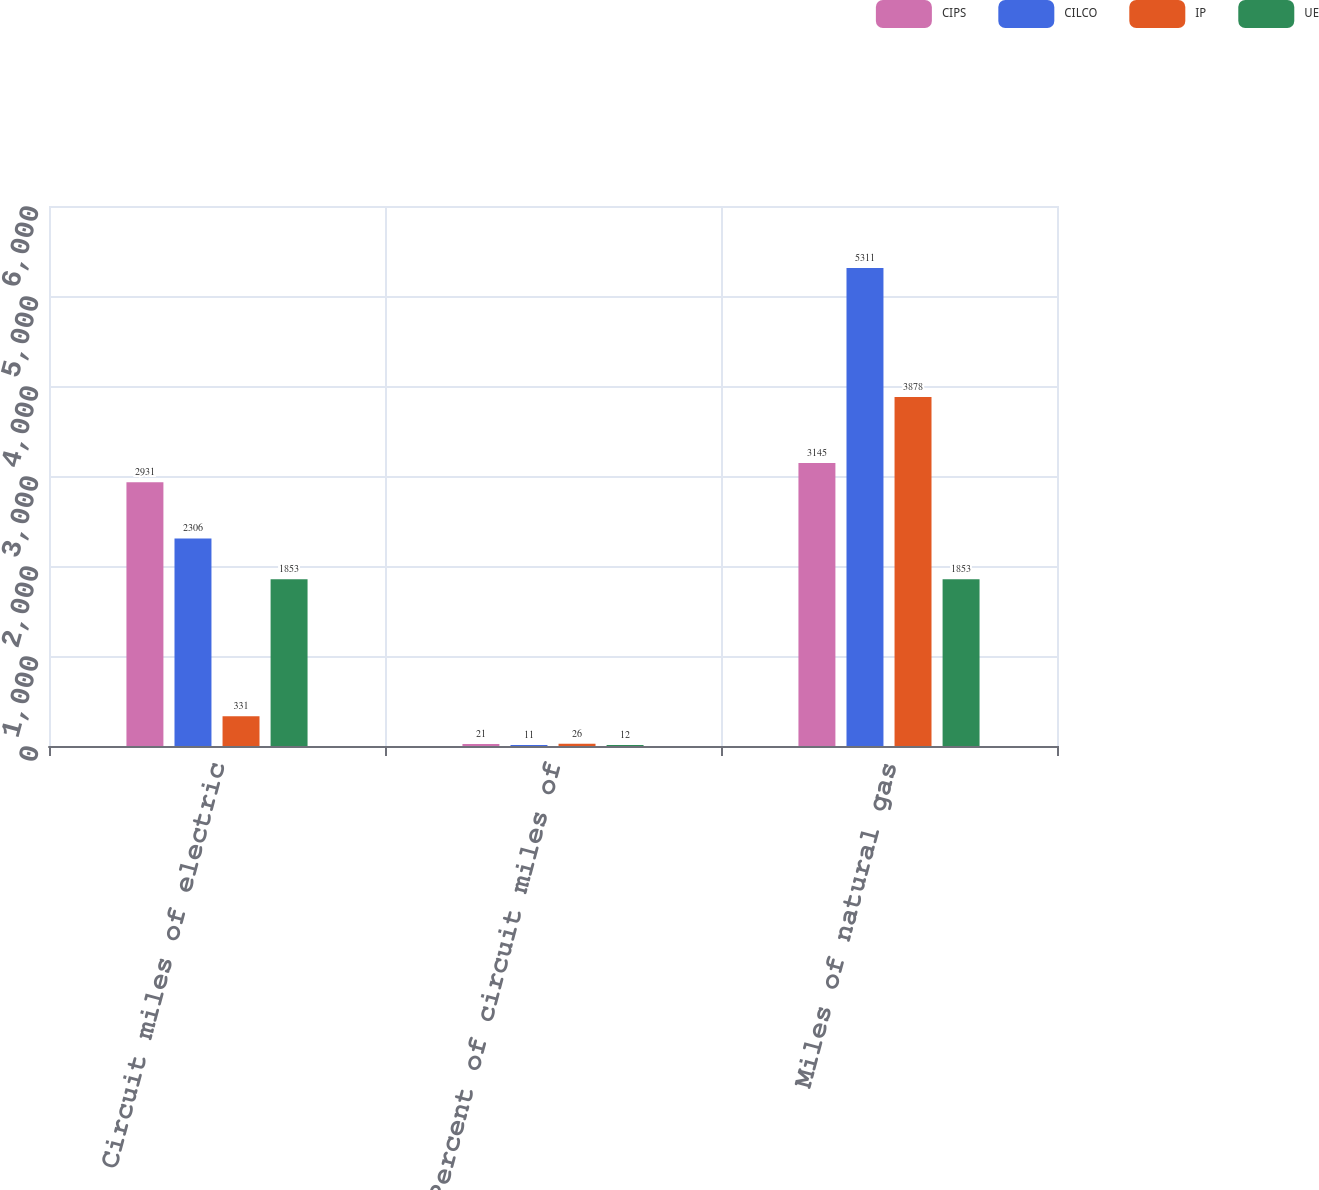Convert chart. <chart><loc_0><loc_0><loc_500><loc_500><stacked_bar_chart><ecel><fcel>Circuit miles of electric<fcel>Percent of circuit miles of<fcel>Miles of natural gas<nl><fcel>CIPS<fcel>2931<fcel>21<fcel>3145<nl><fcel>CILCO<fcel>2306<fcel>11<fcel>5311<nl><fcel>IP<fcel>331<fcel>26<fcel>3878<nl><fcel>UE<fcel>1853<fcel>12<fcel>1853<nl></chart> 